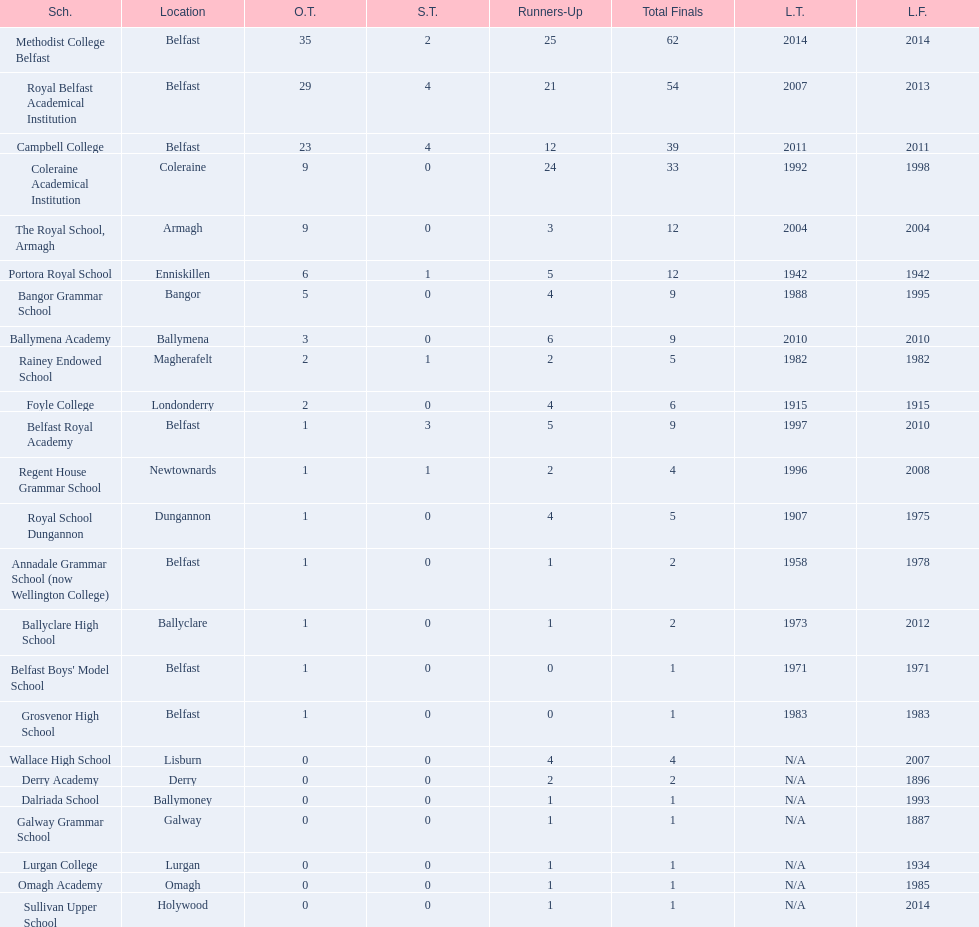Which schools are listed? Methodist College Belfast, Royal Belfast Academical Institution, Campbell College, Coleraine Academical Institution, The Royal School, Armagh, Portora Royal School, Bangor Grammar School, Ballymena Academy, Rainey Endowed School, Foyle College, Belfast Royal Academy, Regent House Grammar School, Royal School Dungannon, Annadale Grammar School (now Wellington College), Ballyclare High School, Belfast Boys' Model School, Grosvenor High School, Wallace High School, Derry Academy, Dalriada School, Galway Grammar School, Lurgan College, Omagh Academy, Sullivan Upper School. When did campbell college win the title last? 2011. When did regent house grammar school win the title last? 1996. Of those two who had the most recent title win? Campbell College. 